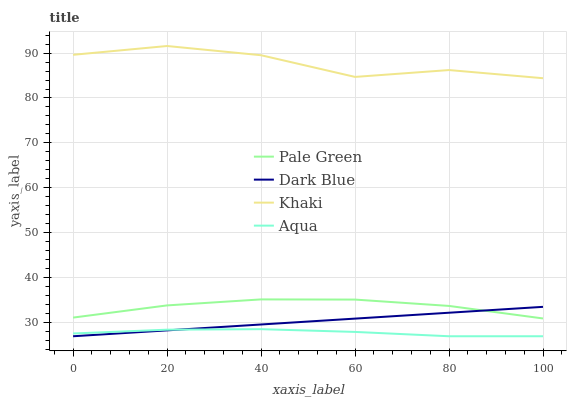Does Pale Green have the minimum area under the curve?
Answer yes or no. No. Does Pale Green have the maximum area under the curve?
Answer yes or no. No. Is Pale Green the smoothest?
Answer yes or no. No. Is Pale Green the roughest?
Answer yes or no. No. Does Pale Green have the lowest value?
Answer yes or no. No. Does Pale Green have the highest value?
Answer yes or no. No. Is Dark Blue less than Khaki?
Answer yes or no. Yes. Is Khaki greater than Aqua?
Answer yes or no. Yes. Does Dark Blue intersect Khaki?
Answer yes or no. No. 